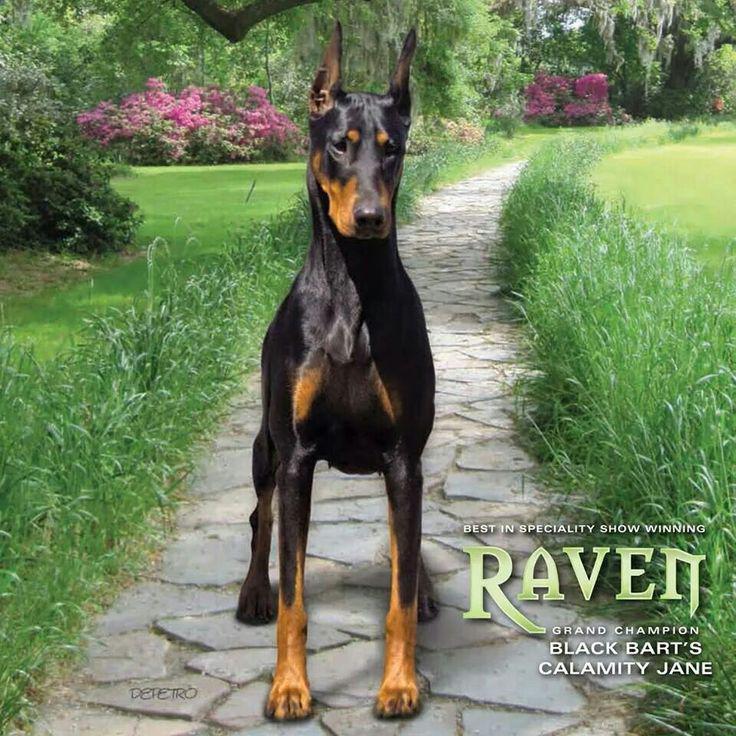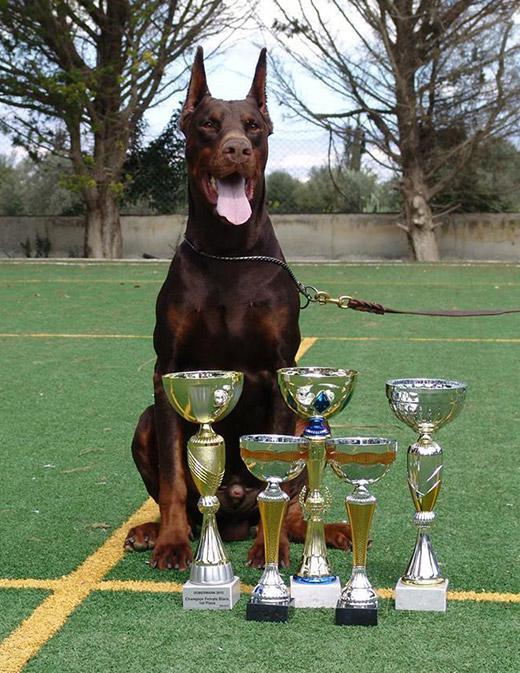The first image is the image on the left, the second image is the image on the right. For the images displayed, is the sentence "The right image contains a reclining doberman with erect ears." factually correct? Answer yes or no. No. The first image is the image on the left, the second image is the image on the right. Examine the images to the left and right. Is the description "There are three dogs sitting or laying on the grass." accurate? Answer yes or no. No. 